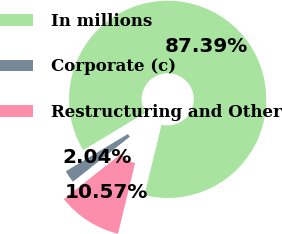Convert chart. <chart><loc_0><loc_0><loc_500><loc_500><pie_chart><fcel>In millions<fcel>Corporate (c)<fcel>Restructuring and Other<nl><fcel>87.39%<fcel>2.04%<fcel>10.57%<nl></chart> 